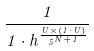Convert formula to latex. <formula><loc_0><loc_0><loc_500><loc_500>\frac { 1 } { 1 \cdot h ^ { \frac { U \times ( 1 \cdot U ) } { 5 ^ { N + 1 } } } }</formula> 